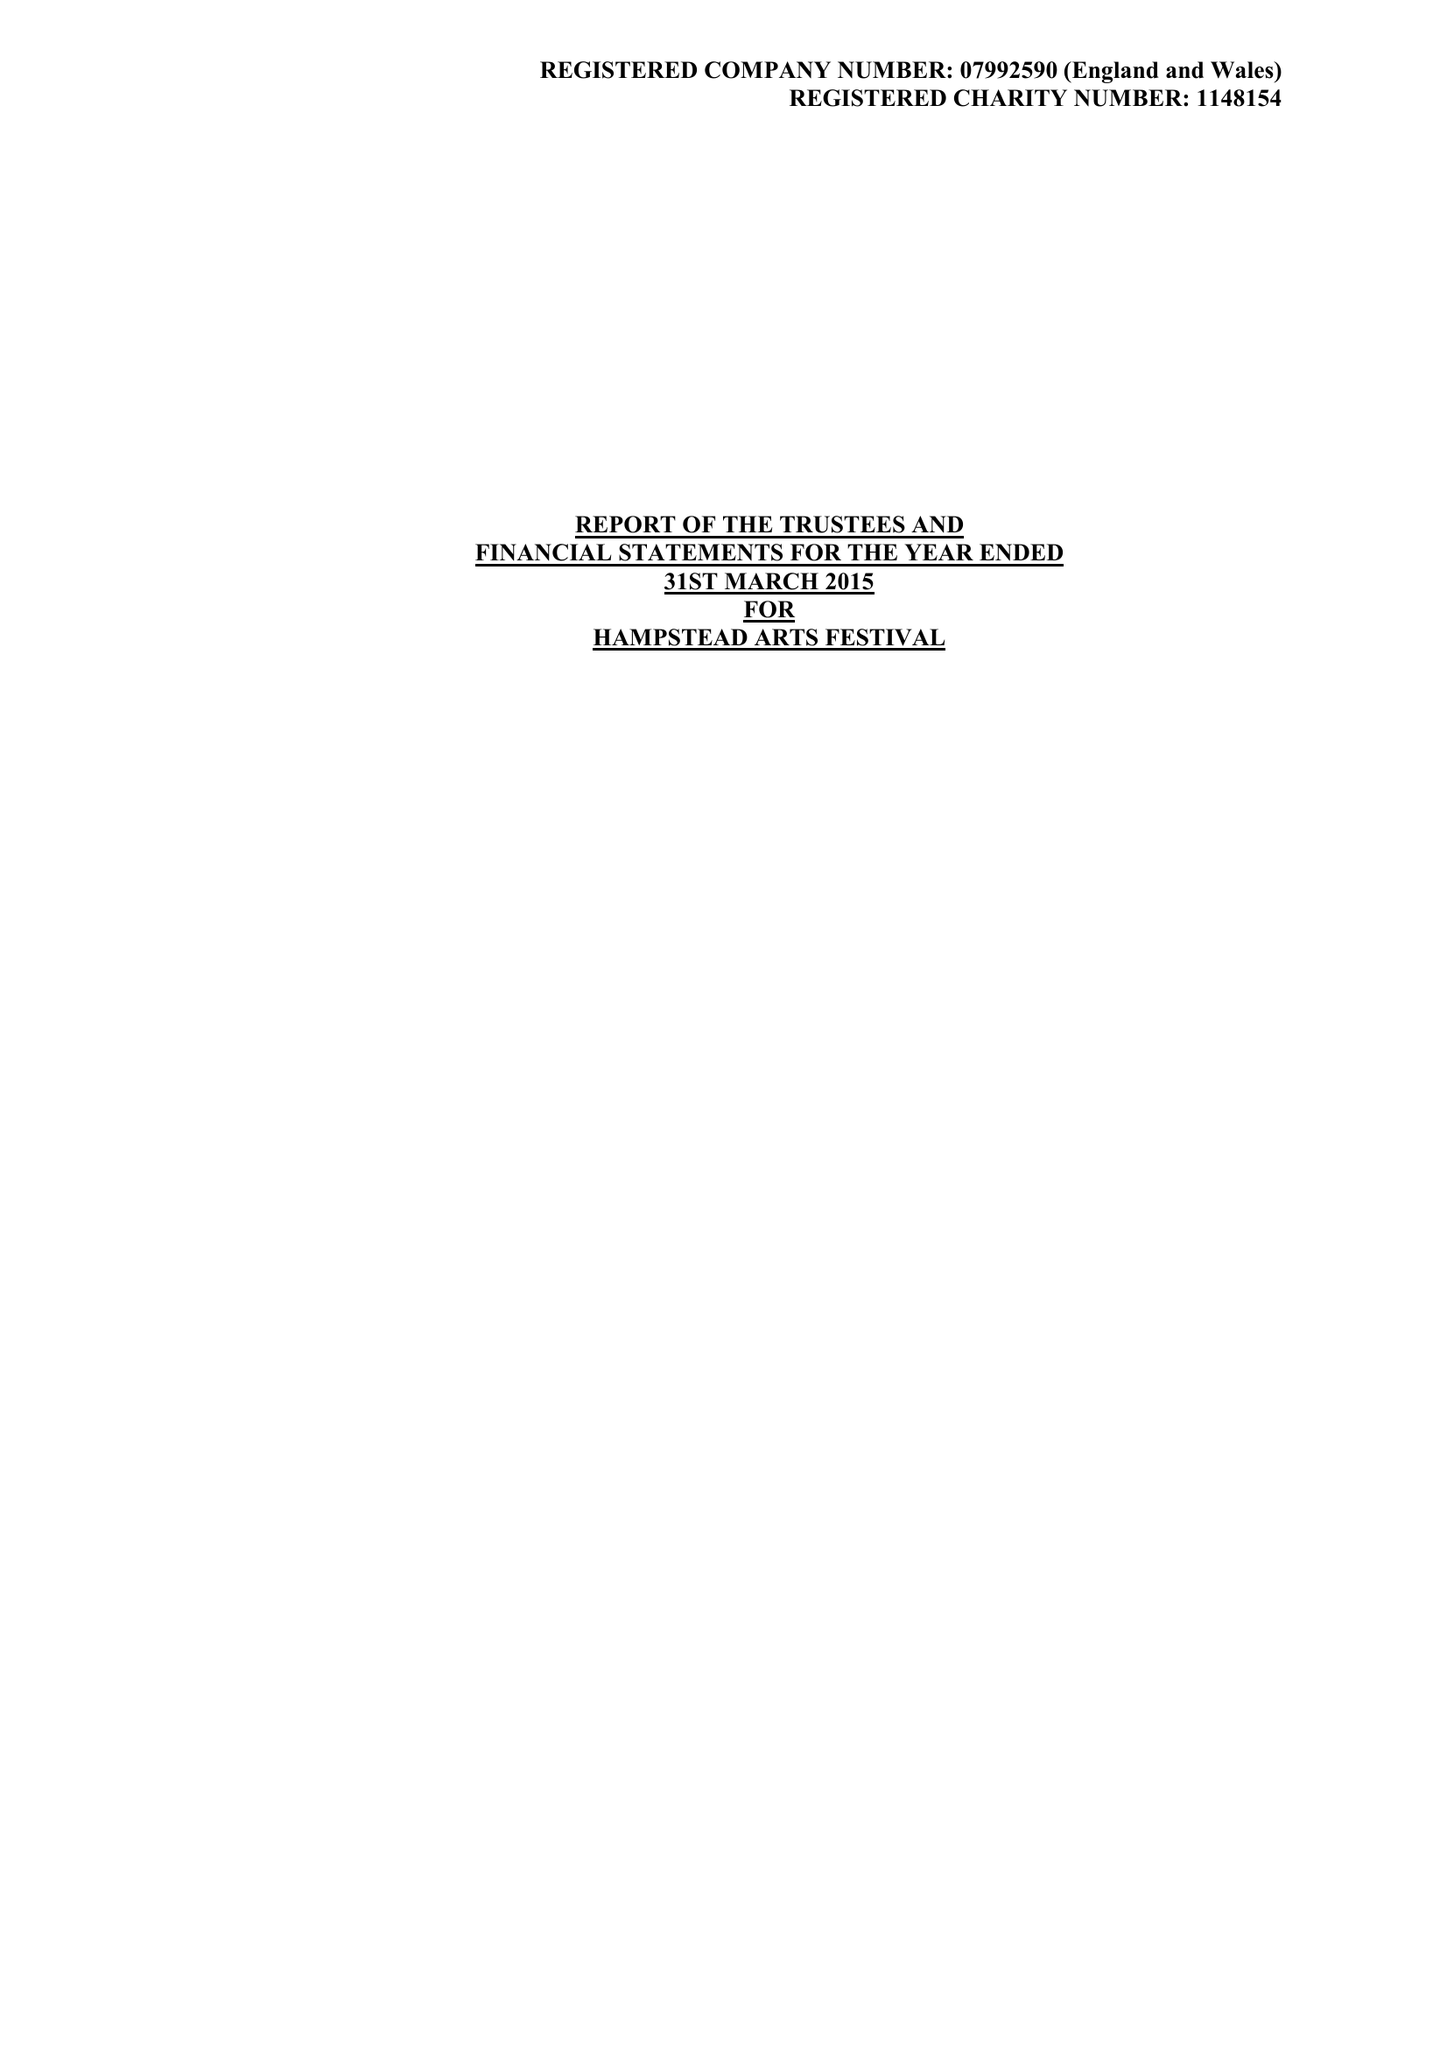What is the value for the charity_name?
Answer the question using a single word or phrase. Hampstead Arts Festival 